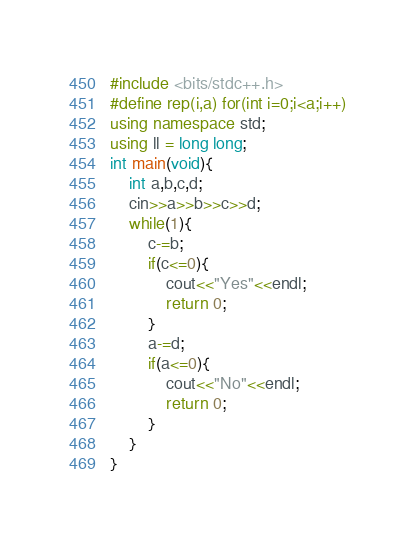<code> <loc_0><loc_0><loc_500><loc_500><_C++_>#include <bits/stdc++.h>
#define rep(i,a) for(int i=0;i<a;i++)
using namespace std;
using ll = long long;
int main(void){
    int a,b,c,d;
    cin>>a>>b>>c>>d;
    while(1){
        c-=b;
        if(c<=0){
            cout<<"Yes"<<endl;
            return 0;
        }
        a-=d;
        if(a<=0){
            cout<<"No"<<endl;
            return 0;
        }
    }
}
</code> 